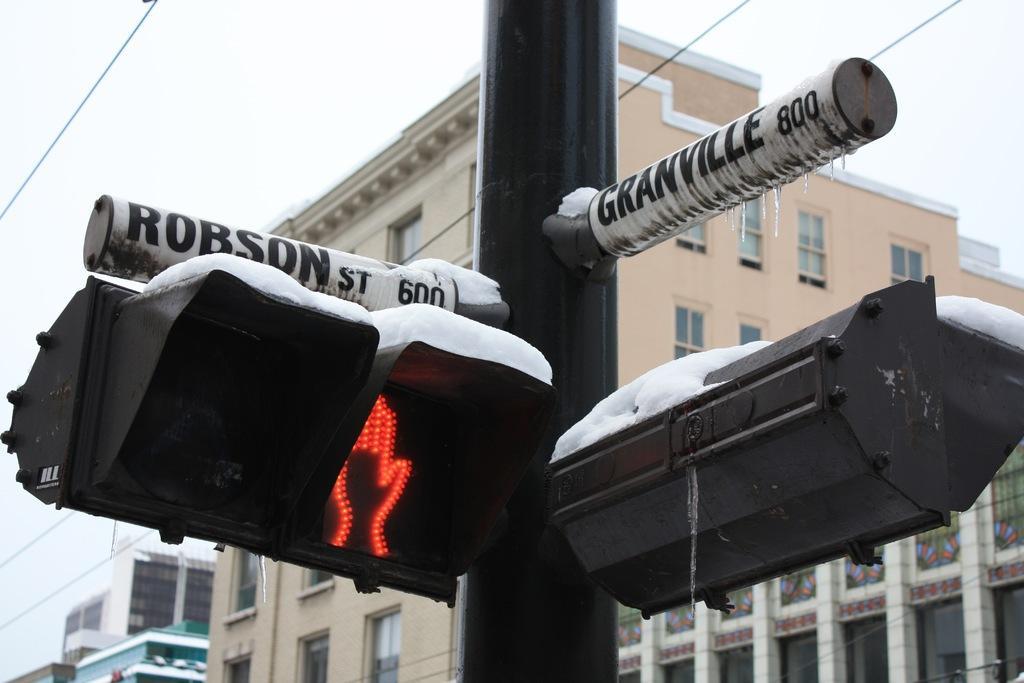Please provide a concise description of this image. In this image, we can see a signal pole in front of the building. In the background of the image, there is a sky. 